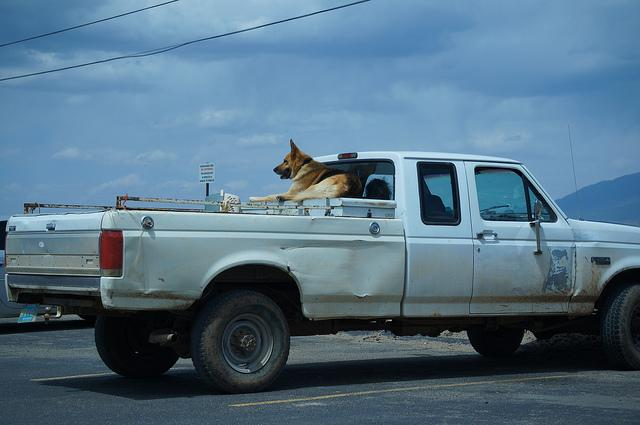Which truck does this dog's owner possess? ford 